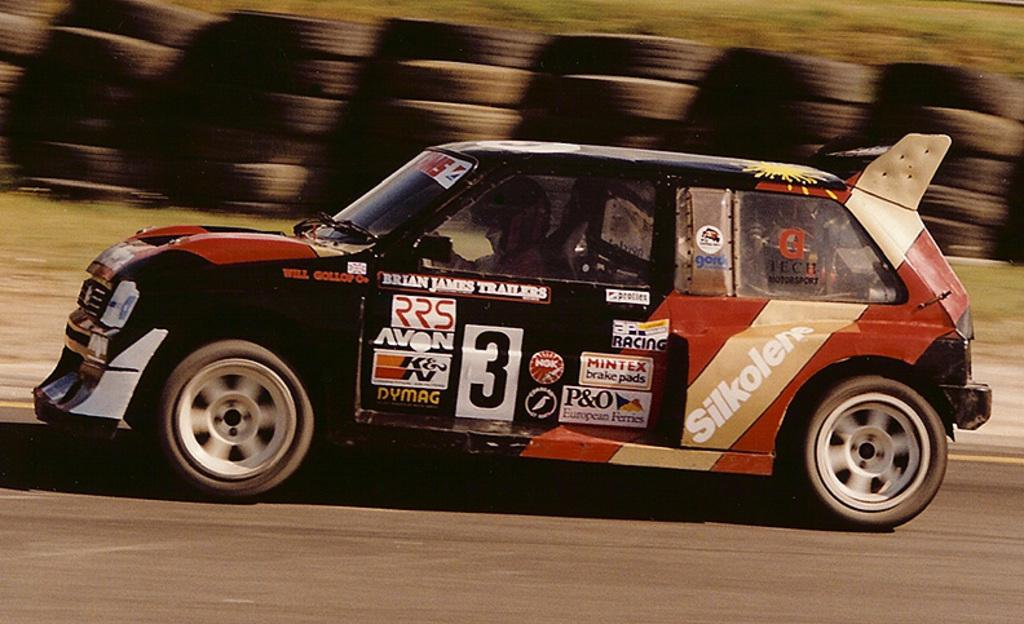What is the main subject of the image? There is a vehicle in the image. Where is the vehicle located? The vehicle is on the road. Who is inside the vehicle? There is a person sitting in the vehicle. What are the wheels of the vehicle called? The vehicle has tires. What type of vegetation can be seen in the image? The image contains grass. Can you hear the person inside the vehicle coughing in the image? There is no sound present in the image, so it is not possible to determine if the person is coughing or not. 